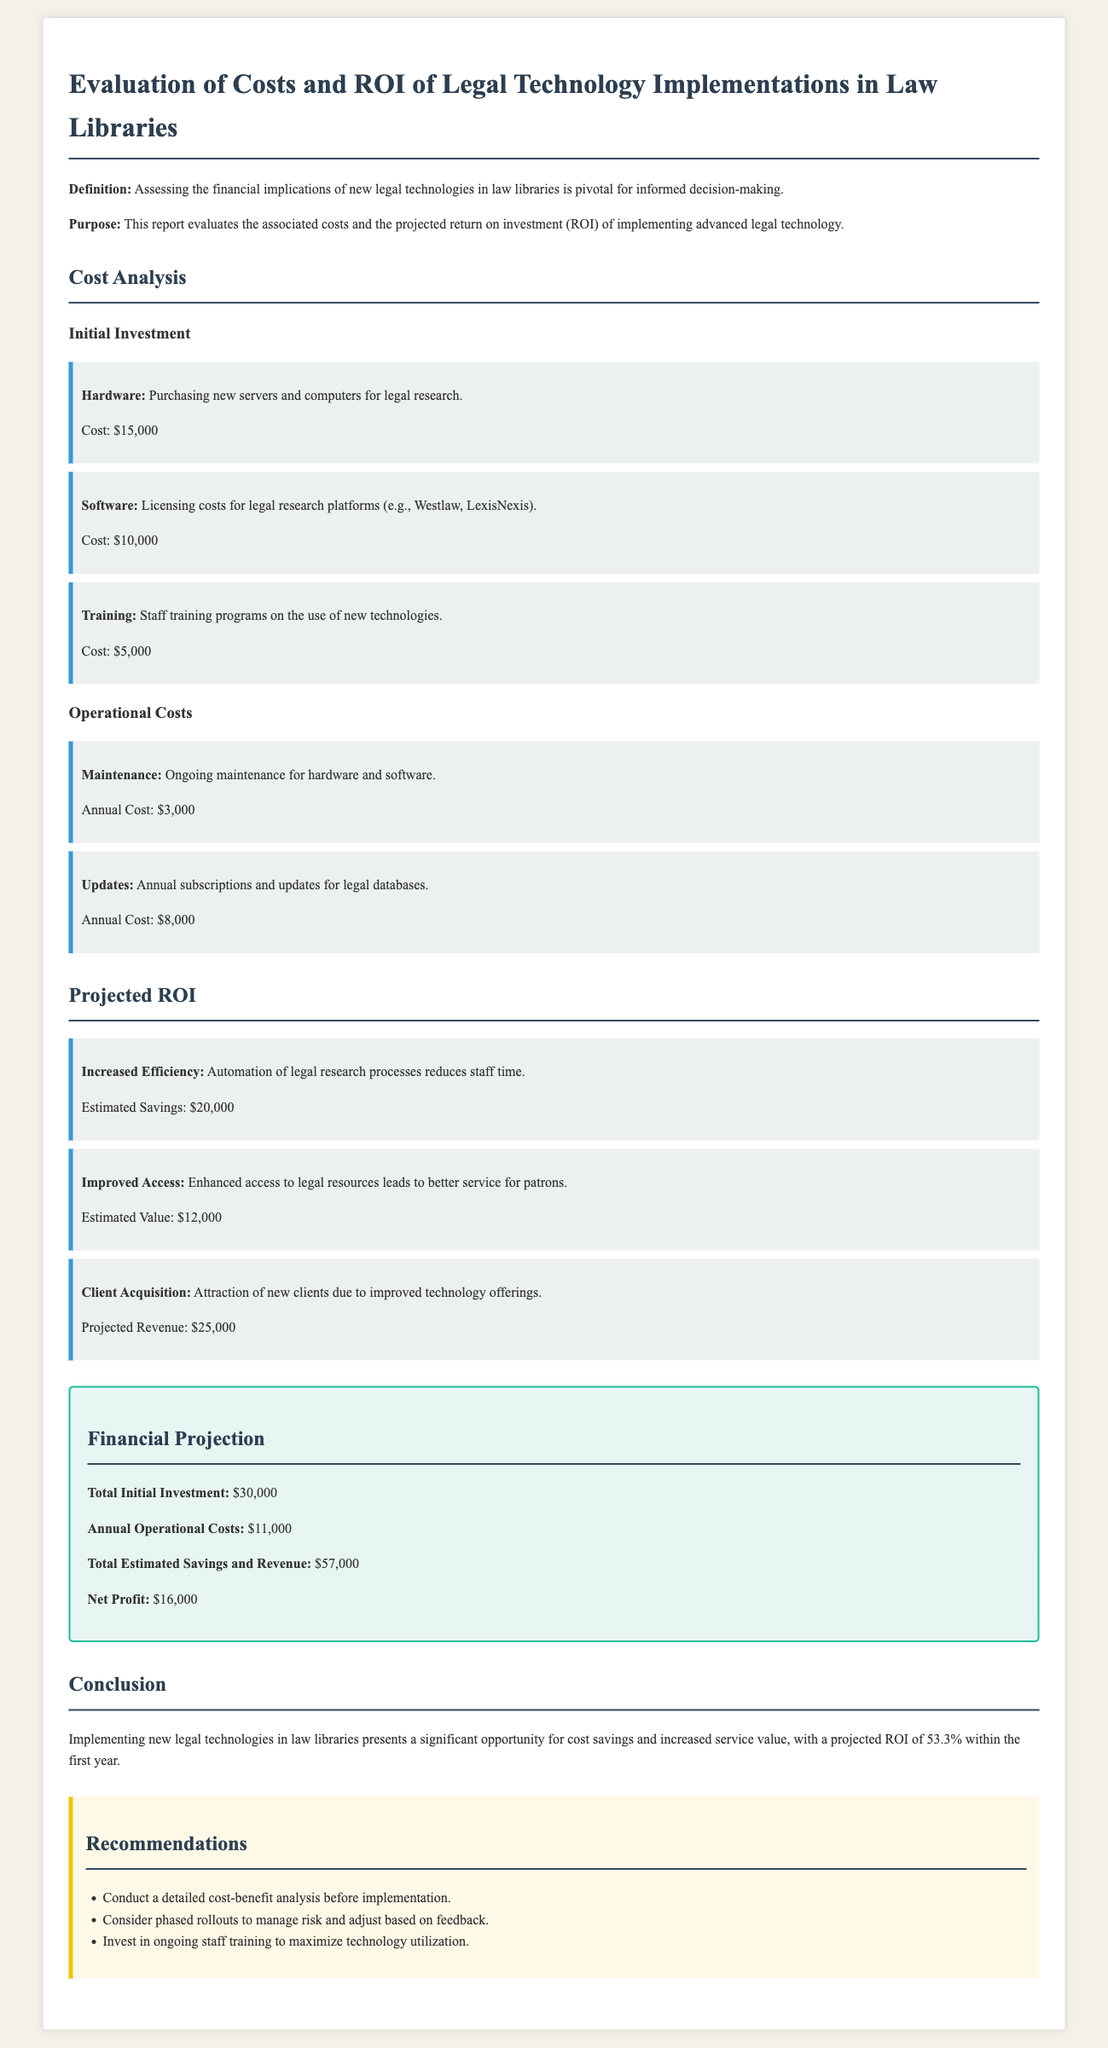What is the total initial investment? The total initial investment is explicitly provided in the financial summary section of the document.
Answer: $30,000 What are the estimated savings from increased efficiency? The estimated savings from increased efficiency is outlined in the projected ROI section.
Answer: $20,000 What is the annual cost of updates for legal databases? The annual cost of updates is mentioned under operational costs.
Answer: $8,000 What is the projected revenue from client acquisition? The projected revenue from client acquisition is detailed in the projected ROI section.
Answer: $25,000 What is the net profit after implementing new legal technology? The net profit is a critical value calculated in the financial projection section.
Answer: $16,000 What recommendation is given regarding staff training? A specific recommendation about staff training is highlighted in the recommendations section.
Answer: Invest in ongoing staff training to maximize technology utilization What is the estimated value attributed to improved access to resources? The estimated value attributed to improved access is specified in the projected ROI section of the document.
Answer: $12,000 What is the percentage of projected ROI within the first year? The projected ROI percentage is explicitly stated in the conclusion of the report.
Answer: 53.3% 